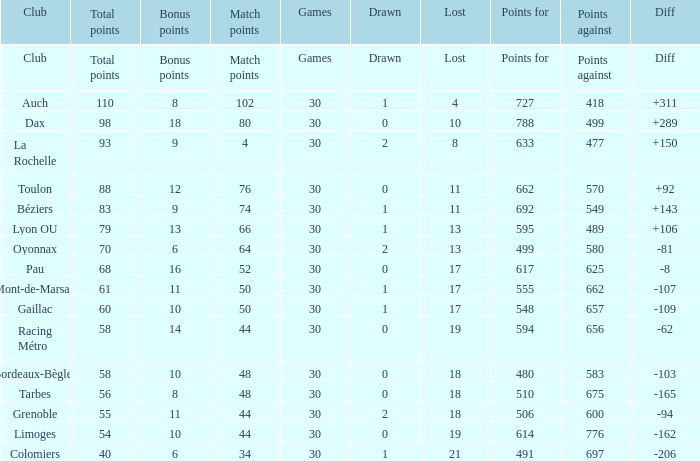What is the amount of match points for a club that lost 18 and has 11 bonus points? 44.0. 